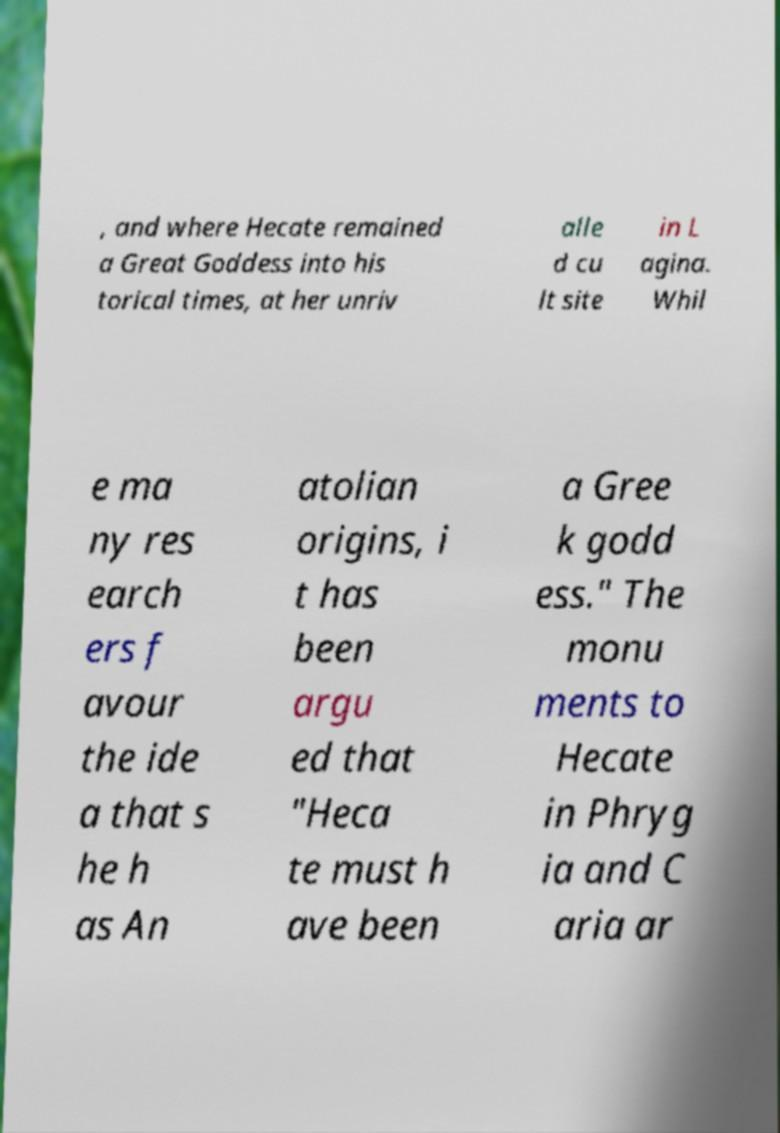What messages or text are displayed in this image? I need them in a readable, typed format. , and where Hecate remained a Great Goddess into his torical times, at her unriv alle d cu lt site in L agina. Whil e ma ny res earch ers f avour the ide a that s he h as An atolian origins, i t has been argu ed that "Heca te must h ave been a Gree k godd ess." The monu ments to Hecate in Phryg ia and C aria ar 